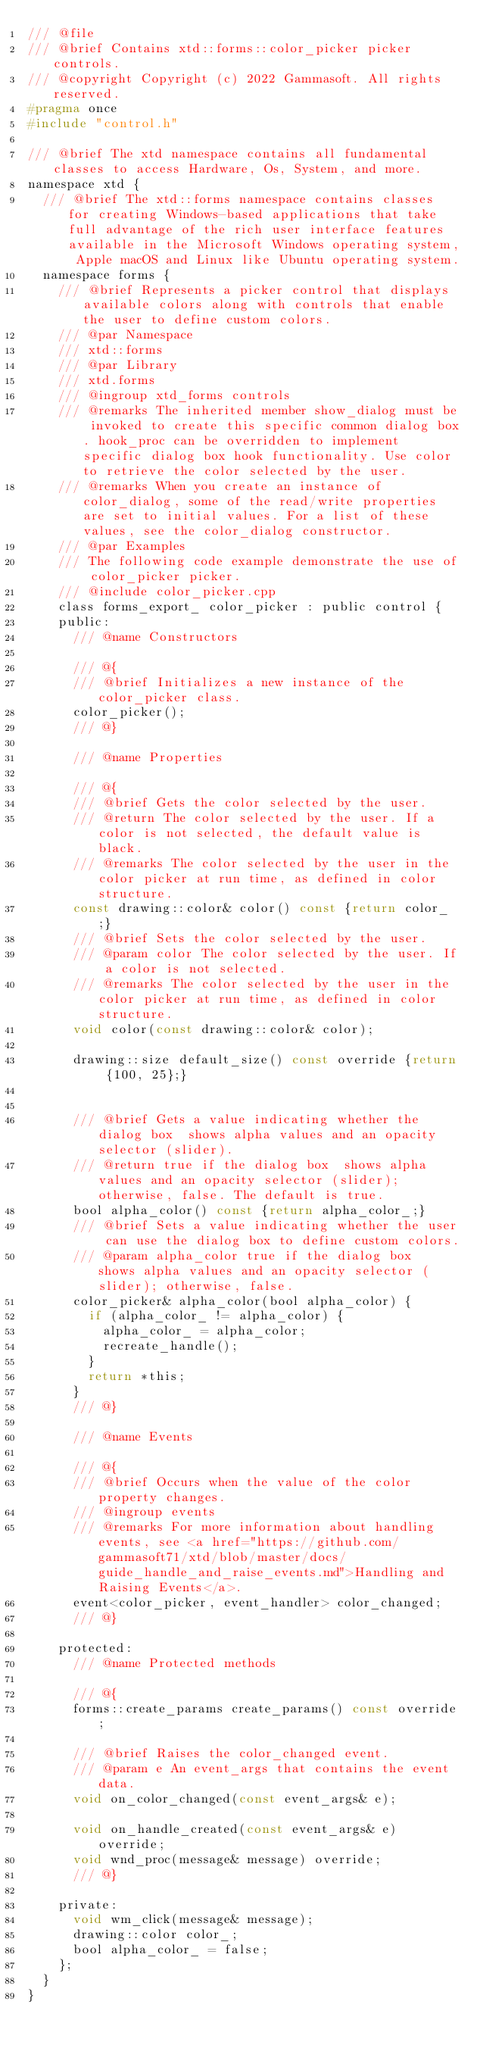<code> <loc_0><loc_0><loc_500><loc_500><_C_>/// @file
/// @brief Contains xtd::forms::color_picker picker controls.
/// @copyright Copyright (c) 2022 Gammasoft. All rights reserved.
#pragma once
#include "control.h"

/// @brief The xtd namespace contains all fundamental classes to access Hardware, Os, System, and more.
namespace xtd {
  /// @brief The xtd::forms namespace contains classes for creating Windows-based applications that take full advantage of the rich user interface features available in the Microsoft Windows operating system, Apple macOS and Linux like Ubuntu operating system.
  namespace forms {
    /// @brief Represents a picker control that displays available colors along with controls that enable the user to define custom colors.
    /// @par Namespace
    /// xtd::forms
    /// @par Library
    /// xtd.forms
    /// @ingroup xtd_forms controls
    /// @remarks The inherited member show_dialog must be invoked to create this specific common dialog box. hook_proc can be overridden to implement specific dialog box hook functionality. Use color to retrieve the color selected by the user.
    /// @remarks When you create an instance of color_dialog, some of the read/write properties are set to initial values. For a list of these values, see the color_dialog constructor.
    /// @par Examples
    /// The following code example demonstrate the use of color_picker picker.
    /// @include color_picker.cpp
    class forms_export_ color_picker : public control {
    public:
      /// @name Constructors
      
      /// @{
      /// @brief Initializes a new instance of the color_picker class.
      color_picker();
      /// @}
      
      /// @name Properties
      
      /// @{
      /// @brief Gets the color selected by the user.
      /// @return The color selected by the user. If a color is not selected, the default value is black.
      /// @remarks The color selected by the user in the color picker at run time, as defined in color structure.
      const drawing::color& color() const {return color_;}
      /// @brief Sets the color selected by the user.
      /// @param color The color selected by the user. If a color is not selected.
      /// @remarks The color selected by the user in the color picker at run time, as defined in color structure.
      void color(const drawing::color& color);
      
      drawing::size default_size() const override {return {100, 25};}
      
      
      /// @brief Gets a value indicating whether the dialog box  shows alpha values and an opacity selector (slider).
      /// @return true if the dialog box  shows alpha values and an opacity selector (slider); otherwise, false. The default is true.
      bool alpha_color() const {return alpha_color_;}
      /// @brief Sets a value indicating whether the user can use the dialog box to define custom colors.
      /// @param alpha_color true if the dialog box  shows alpha values and an opacity selector (slider); otherwise, false.
      color_picker& alpha_color(bool alpha_color) {
        if (alpha_color_ != alpha_color) {
          alpha_color_ = alpha_color;
          recreate_handle();
        }
        return *this;
      }
      /// @}
      
      /// @name Events
      
      /// @{
      /// @brief Occurs when the value of the color property changes.
      /// @ingroup events
      /// @remarks For more information about handling events, see <a href="https://github.com/gammasoft71/xtd/blob/master/docs/guide_handle_and_raise_events.md">Handling and Raising Events</a>.
      event<color_picker, event_handler> color_changed;
      /// @}
      
    protected:
      /// @name Protected methods
      
      /// @{
      forms::create_params create_params() const override;
      
      /// @brief Raises the color_changed event.
      /// @param e An event_args that contains the event data.
      void on_color_changed(const event_args& e);
      
      void on_handle_created(const event_args& e) override;
      void wnd_proc(message& message) override;
      /// @}
      
    private:
      void wm_click(message& message);
      drawing::color color_;
      bool alpha_color_ = false;
    };
  }
}
</code> 